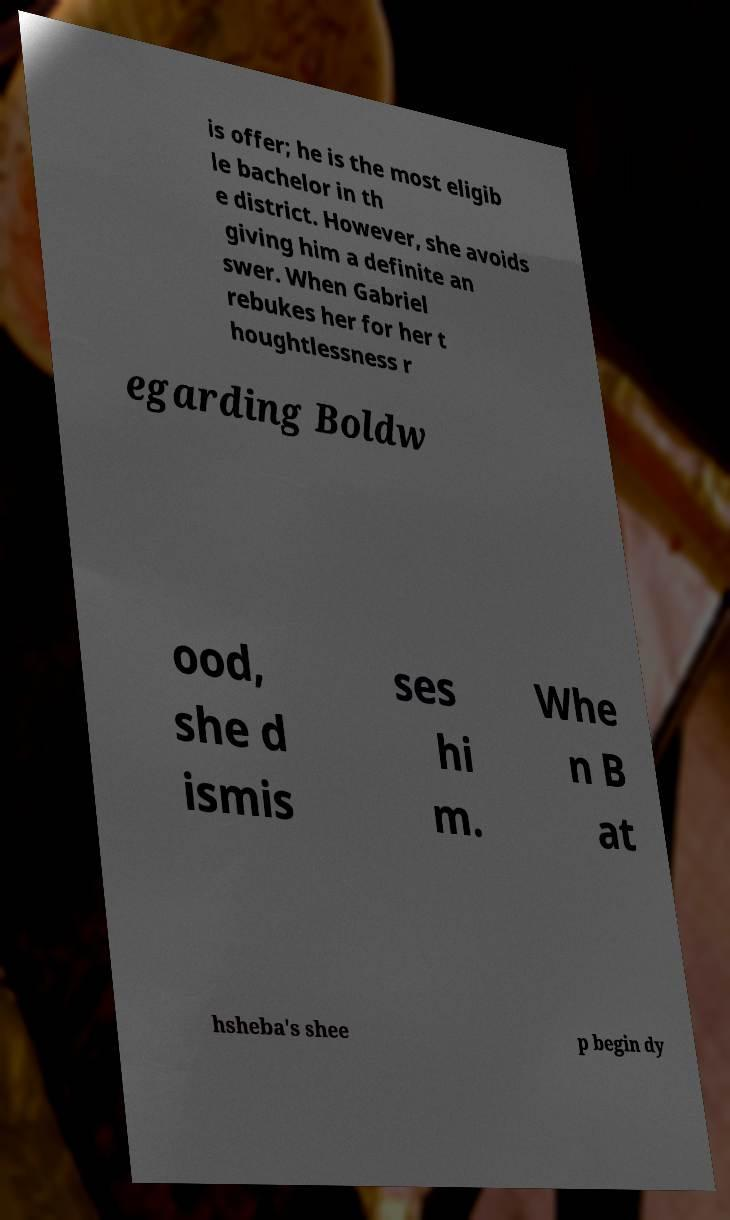Could you assist in decoding the text presented in this image and type it out clearly? is offer; he is the most eligib le bachelor in th e district. However, she avoids giving him a definite an swer. When Gabriel rebukes her for her t houghtlessness r egarding Boldw ood, she d ismis ses hi m. Whe n B at hsheba's shee p begin dy 